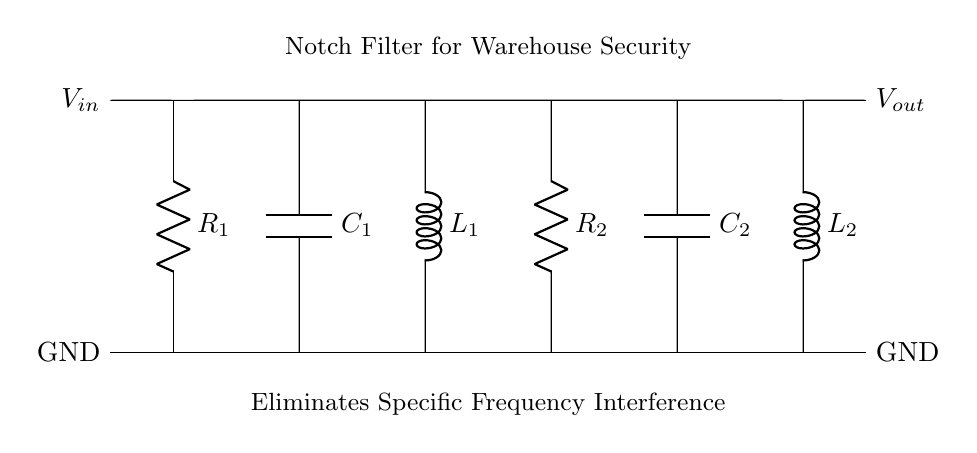What is the type of filter used in this circuit? The circuit explicitly mentions it is a "Notch Filter" which is designed to eliminate specific frequency interference. The labeling in the diagram confirms this designation.
Answer: Notch Filter What types of components are present in the circuit? The circuit contains resistors, capacitors, and inductors. Specifically, two resistors, two capacitors, and two inductors are identified in the diagram with labels R1, R2, C1, C2, L1, and L2.
Answer: Resistors, capacitors, inductors How many resistors are used in this notch filter? The circuit labels R1 and R2 as the two resistors present. By counting the labeled components, we find there are two resistors in total.
Answer: Two What is the purpose of the components in this circuit? The components serve to create a notch filter configuration, where the resistors control the amount of signal that passes, the capacitors manage the frequency response, and the inductors help to shape the attenuation characteristics at specific frequencies. This combination achieves the goal of eliminating interference.
Answer: Eliminate specific frequency interference Which component directly connects to the input voltage? The component that connects directly to the input voltage, denoted as V_in, is R1, established by the vertical line leading from the top to the ground. R1 is the first element in the top row of the circuit.
Answer: R1 